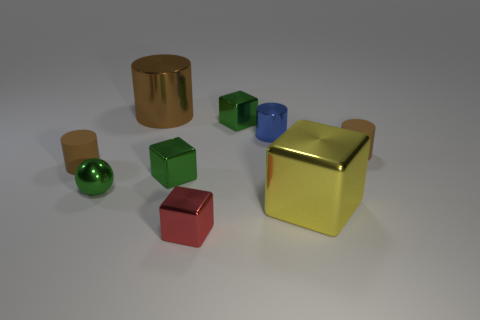Is there any other thing that has the same shape as the yellow metal object?
Make the answer very short. Yes. What number of things are either green metallic balls or tiny green metal objects?
Your answer should be very brief. 3. What is the size of the yellow object that is the same shape as the tiny red object?
Provide a short and direct response. Large. Is there any other thing that is the same size as the red shiny block?
Give a very brief answer. Yes. What number of other objects are the same color as the small metal sphere?
Your answer should be very brief. 2. How many cylinders are either tiny brown rubber things or large yellow metallic objects?
Your response must be concise. 2. The big metal object on the left side of the block in front of the yellow cube is what color?
Your answer should be very brief. Brown. The big brown shiny object has what shape?
Ensure brevity in your answer.  Cylinder. Is the size of the matte cylinder to the left of the red thing the same as the big shiny cube?
Your answer should be compact. No. Is there a small green cube made of the same material as the yellow object?
Keep it short and to the point. Yes. 